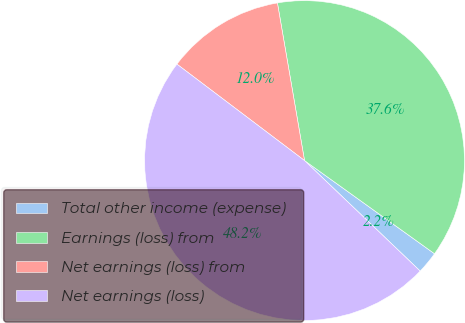Convert chart. <chart><loc_0><loc_0><loc_500><loc_500><pie_chart><fcel>Total other income (expense)<fcel>Earnings (loss) from<fcel>Net earnings (loss) from<fcel>Net earnings (loss)<nl><fcel>2.24%<fcel>37.61%<fcel>11.99%<fcel>48.16%<nl></chart> 